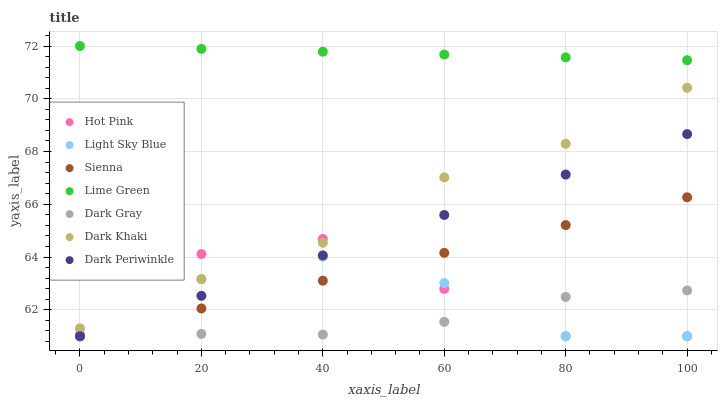Does Dark Gray have the minimum area under the curve?
Answer yes or no. Yes. Does Lime Green have the maximum area under the curve?
Answer yes or no. Yes. Does Hot Pink have the minimum area under the curve?
Answer yes or no. No. Does Hot Pink have the maximum area under the curve?
Answer yes or no. No. Is Dark Periwinkle the smoothest?
Answer yes or no. Yes. Is Hot Pink the roughest?
Answer yes or no. Yes. Is Sienna the smoothest?
Answer yes or no. No. Is Sienna the roughest?
Answer yes or no. No. Does Dark Gray have the lowest value?
Answer yes or no. Yes. Does Dark Khaki have the lowest value?
Answer yes or no. No. Does Lime Green have the highest value?
Answer yes or no. Yes. Does Hot Pink have the highest value?
Answer yes or no. No. Is Hot Pink less than Lime Green?
Answer yes or no. Yes. Is Dark Khaki greater than Light Sky Blue?
Answer yes or no. Yes. Does Dark Periwinkle intersect Light Sky Blue?
Answer yes or no. Yes. Is Dark Periwinkle less than Light Sky Blue?
Answer yes or no. No. Is Dark Periwinkle greater than Light Sky Blue?
Answer yes or no. No. Does Hot Pink intersect Lime Green?
Answer yes or no. No. 